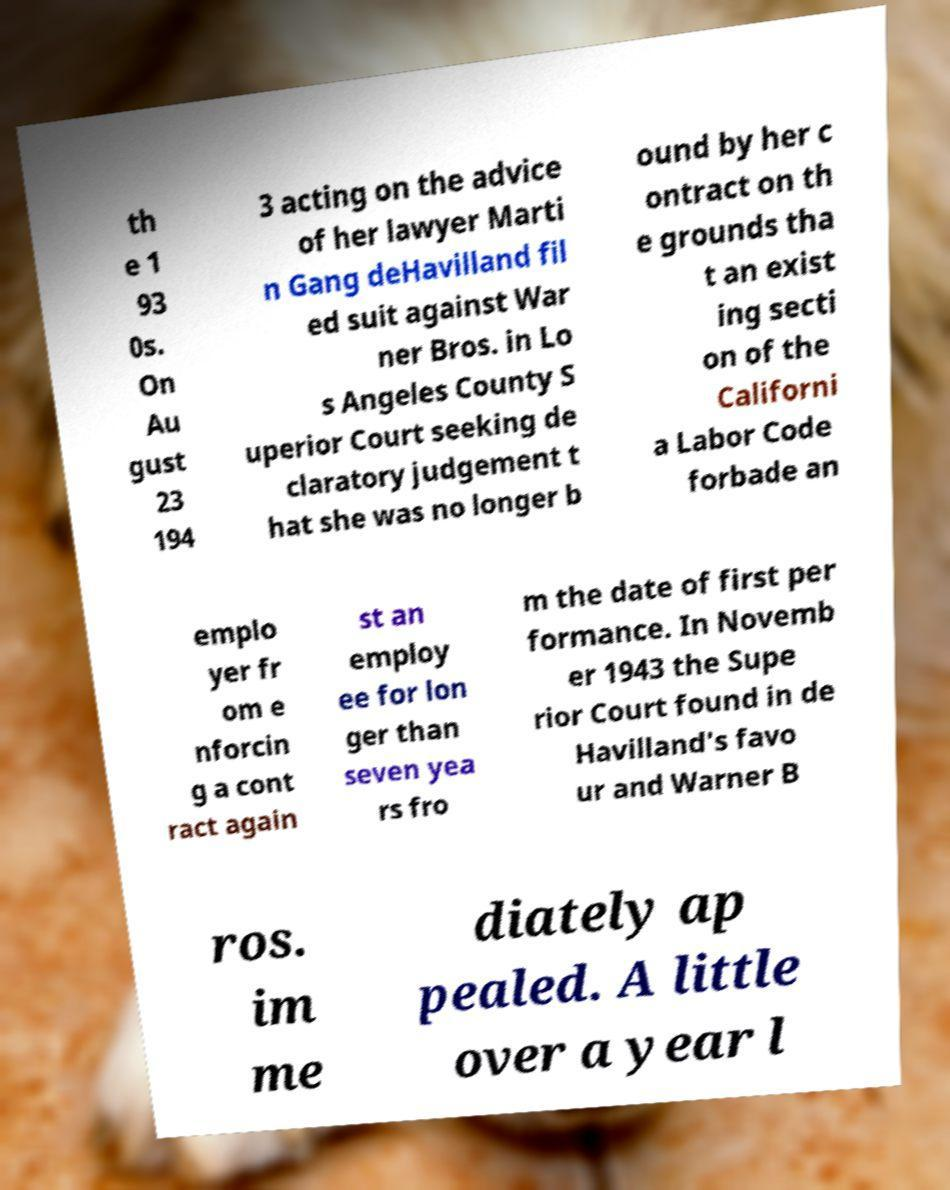Can you accurately transcribe the text from the provided image for me? th e 1 93 0s. On Au gust 23 194 3 acting on the advice of her lawyer Marti n Gang deHavilland fil ed suit against War ner Bros. in Lo s Angeles County S uperior Court seeking de claratory judgement t hat she was no longer b ound by her c ontract on th e grounds tha t an exist ing secti on of the Californi a Labor Code forbade an emplo yer fr om e nforcin g a cont ract again st an employ ee for lon ger than seven yea rs fro m the date of first per formance. In Novemb er 1943 the Supe rior Court found in de Havilland's favo ur and Warner B ros. im me diately ap pealed. A little over a year l 